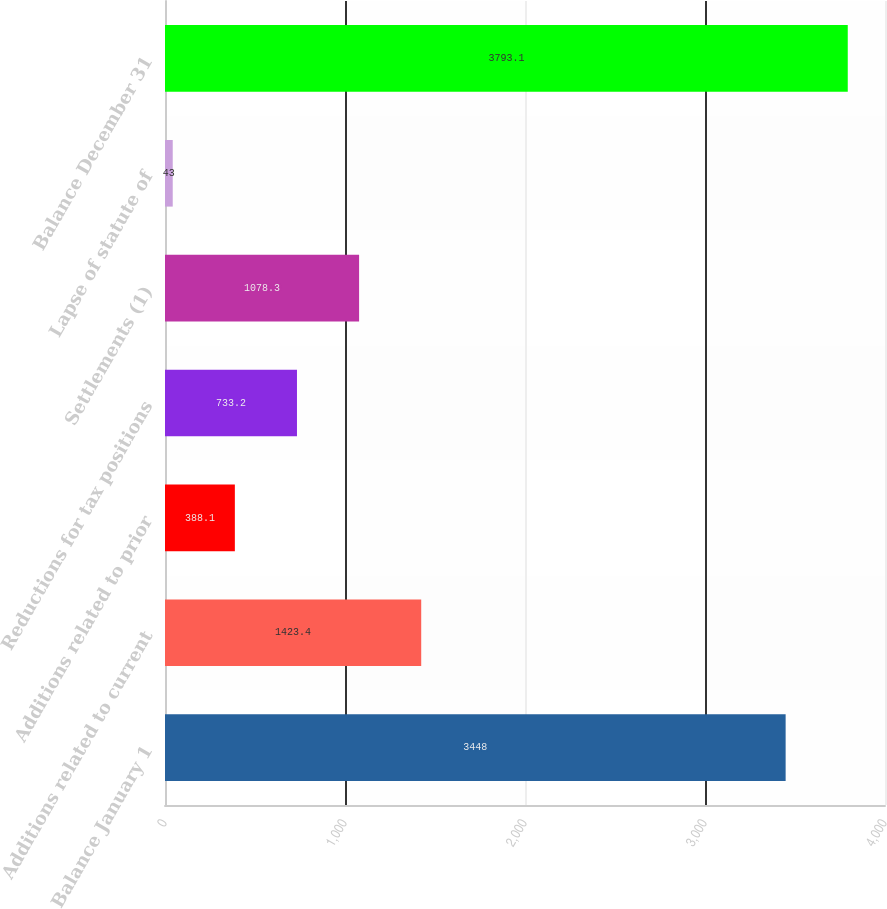Convert chart. <chart><loc_0><loc_0><loc_500><loc_500><bar_chart><fcel>Balance January 1<fcel>Additions related to current<fcel>Additions related to prior<fcel>Reductions for tax positions<fcel>Settlements (1)<fcel>Lapse of statute of<fcel>Balance December 31<nl><fcel>3448<fcel>1423.4<fcel>388.1<fcel>733.2<fcel>1078.3<fcel>43<fcel>3793.1<nl></chart> 